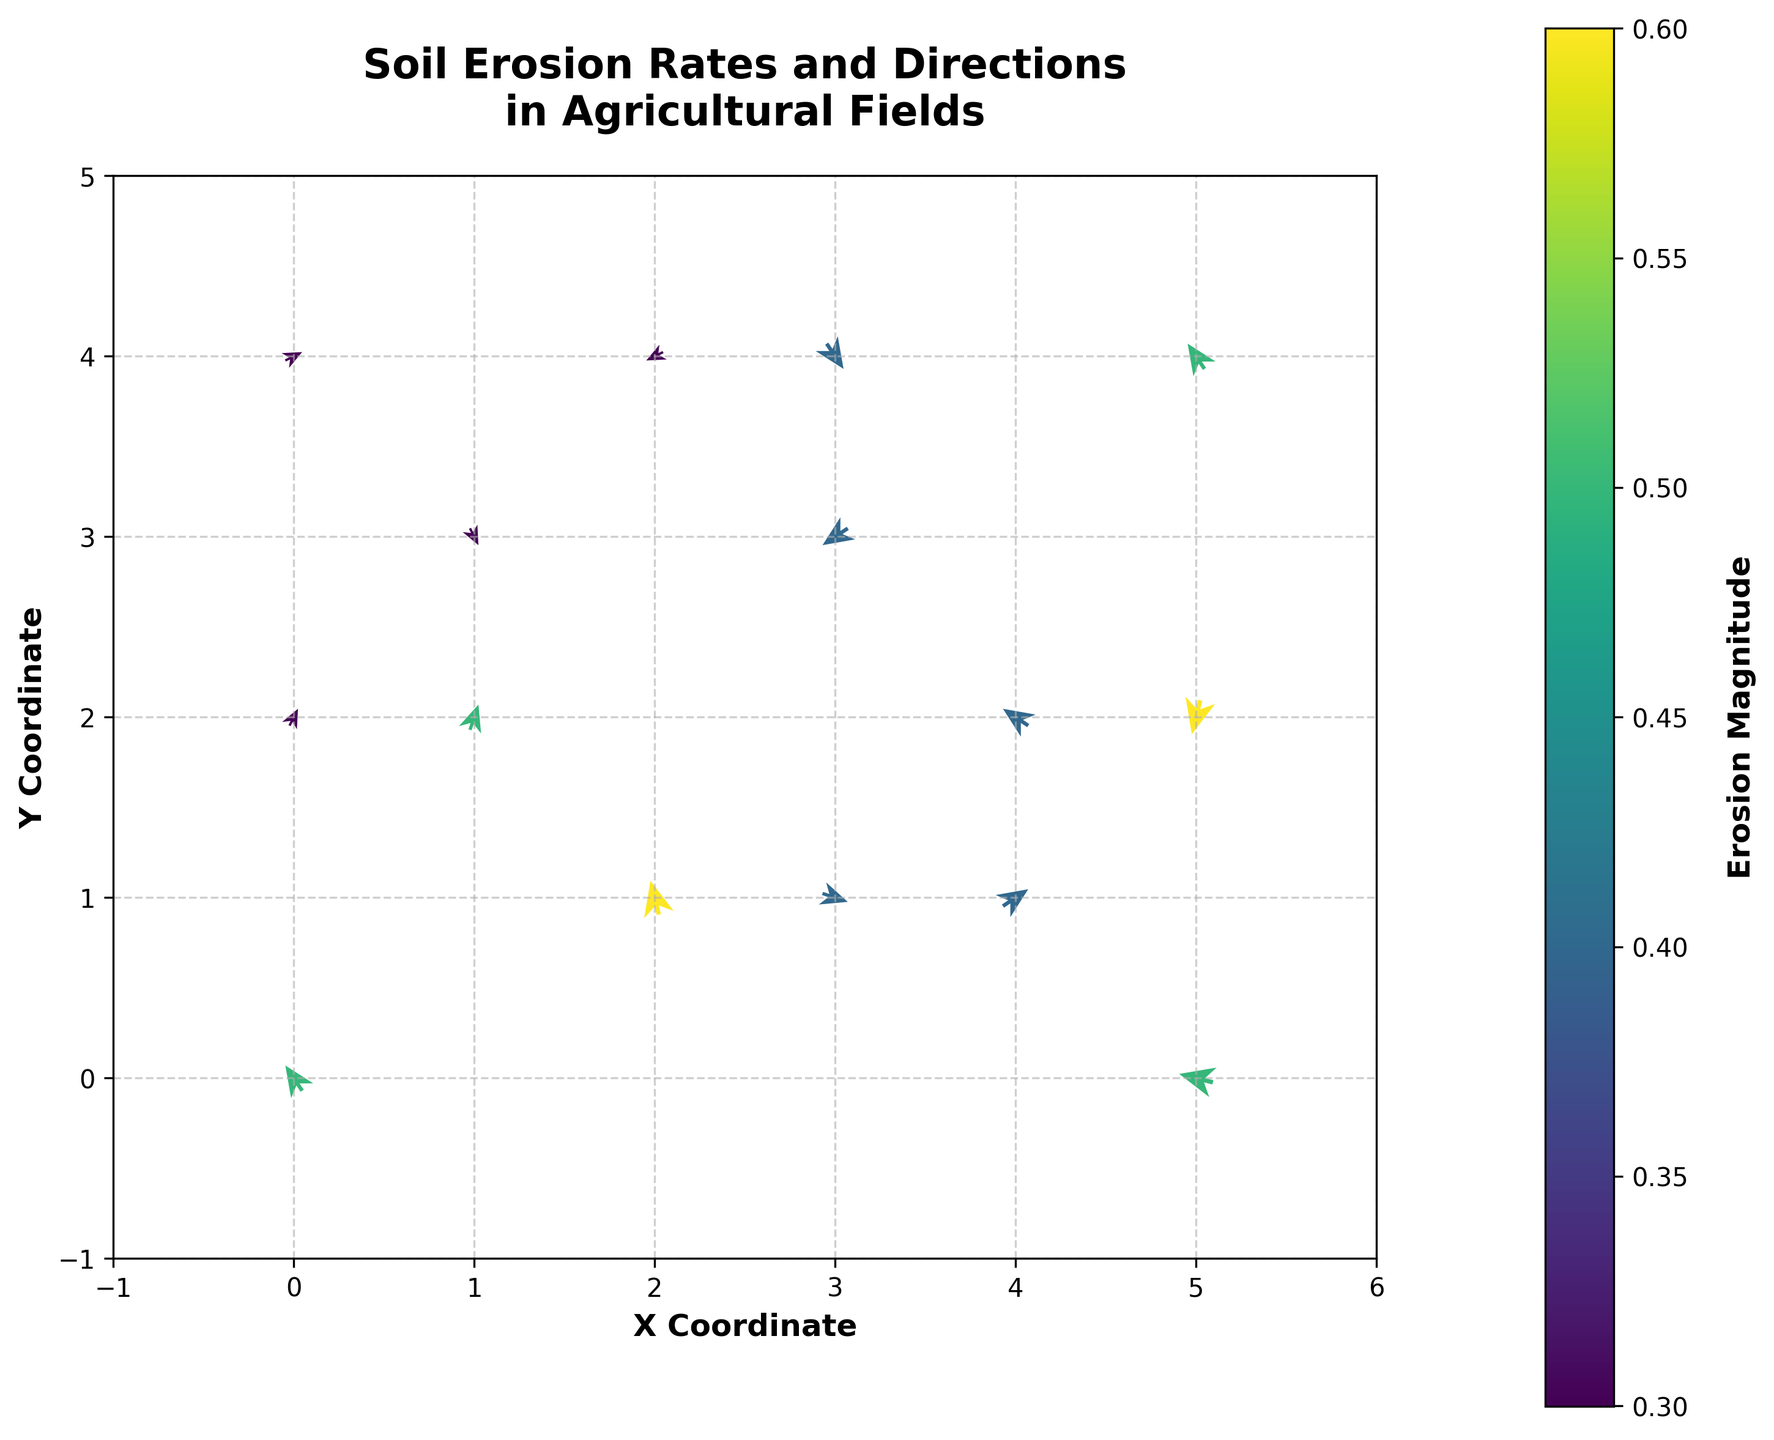What is the title of the plot? The title is shown prominently at the top of the plot. It reads "Soil Erosion Rates and Directions\nin Agricultural Fields".
Answer: Soil Erosion Rates and Directions in Agricultural Fields How many data points are shown in the plot? The data points are represented by the origin point of each arrow. Counting the number of arrows in the plot gives us the total number of data points. There are 15 arrows in the plot.
Answer: 15 Which data point has the highest erosion magnitude? The erosion magnitude is represented by the color intensity of the arrows. The color bar on the right helps in identifying this. The arrow at the coordinate (2, 1) has the deepest color, which corresponds to the highest magnitude of 0.6.
Answer: (2, 1) What are the x and y-axis labels? The labels of the axes are indicated along the respective axes. The x-axis is labeled "X Coordinate," and the y-axis is labeled "Y Coordinate".
Answer: X Coordinate and Y Coordinate Which direction does the arrow at (4, 1) point? The direction of the arrow can be determined from its orientation. The arrow at (4, 1) points towards the upper-right, indicating positive u and v components.
Answer: Upper-right What's the difference in erosion magnitudes between the data points at (5, 2) and (4, 2)? The color intensity of the arrows can be checked against the color bar. The magnitudes are 0.6 and 0.4 for (5, 2) and (4, 2) respectively. The difference is 0.6 - 0.4 = 0.2.
Answer: 0.2 Which data point has the arrow pointing most directly downward? The most downward-pointing arrow will have a significant negative v component and minimal u component. The arrow at (5, 2) points steeply downward.
Answer: (5, 2) What is the average erosion magnitude of the points along the y=2 line? Identify the points along the y=2 line. They are: (0, 2), (4, 2), (5, 2). Their magnitudes are 0.3, 0.4, 0.6 respectively. The average is (0.3 + 0.4 + 0.6) / 3 = 0.433.
Answer: 0.433 What does the color bar represent? The color bar indicates the range of erosion magnitudes, with the color transitioning from lower values to higher values. The label on the color bar reads "Erosion Magnitude".
Answer: Erosion Magnitude 